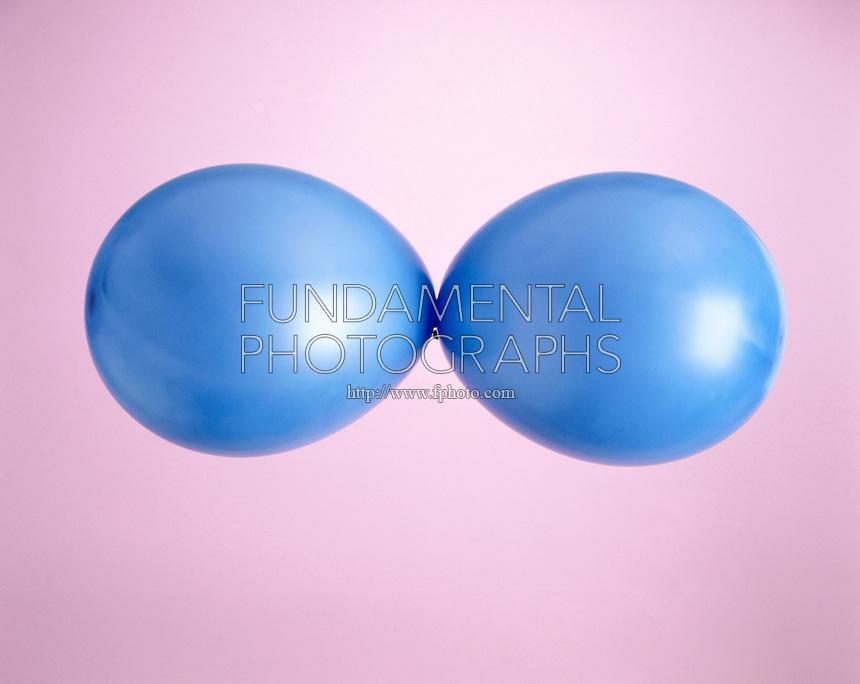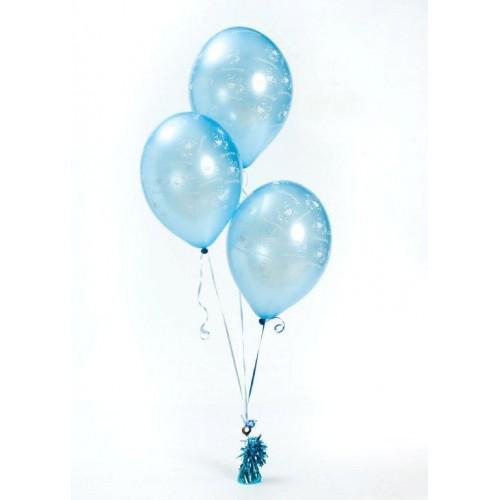The first image is the image on the left, the second image is the image on the right. Evaluate the accuracy of this statement regarding the images: "AN image shows at least three blue balloons displayed with knot ends joined at the center.". Is it true? Answer yes or no. No. The first image is the image on the left, the second image is the image on the right. For the images displayed, is the sentence "There are no more than three balloons in each image." factually correct? Answer yes or no. Yes. 